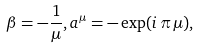Convert formula to latex. <formula><loc_0><loc_0><loc_500><loc_500>\beta = - \frac { 1 } { \mu } , a ^ { \mu } = - \exp ( i \, \pi \, \mu ) ,</formula> 